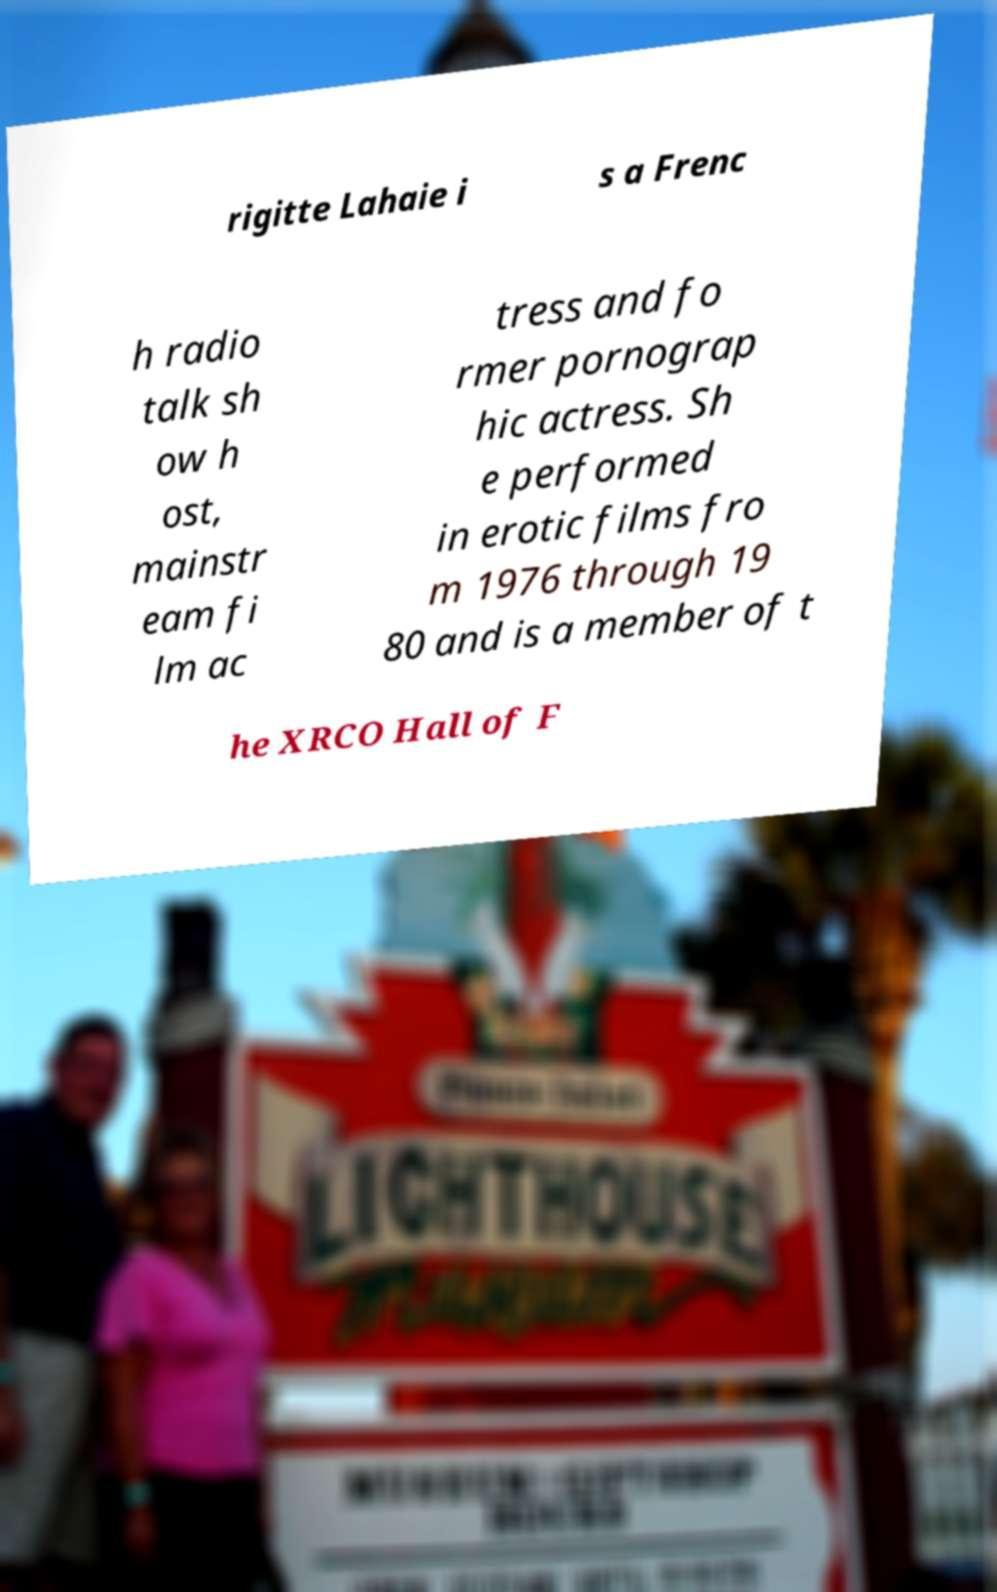Can you read and provide the text displayed in the image?This photo seems to have some interesting text. Can you extract and type it out for me? rigitte Lahaie i s a Frenc h radio talk sh ow h ost, mainstr eam fi lm ac tress and fo rmer pornograp hic actress. Sh e performed in erotic films fro m 1976 through 19 80 and is a member of t he XRCO Hall of F 